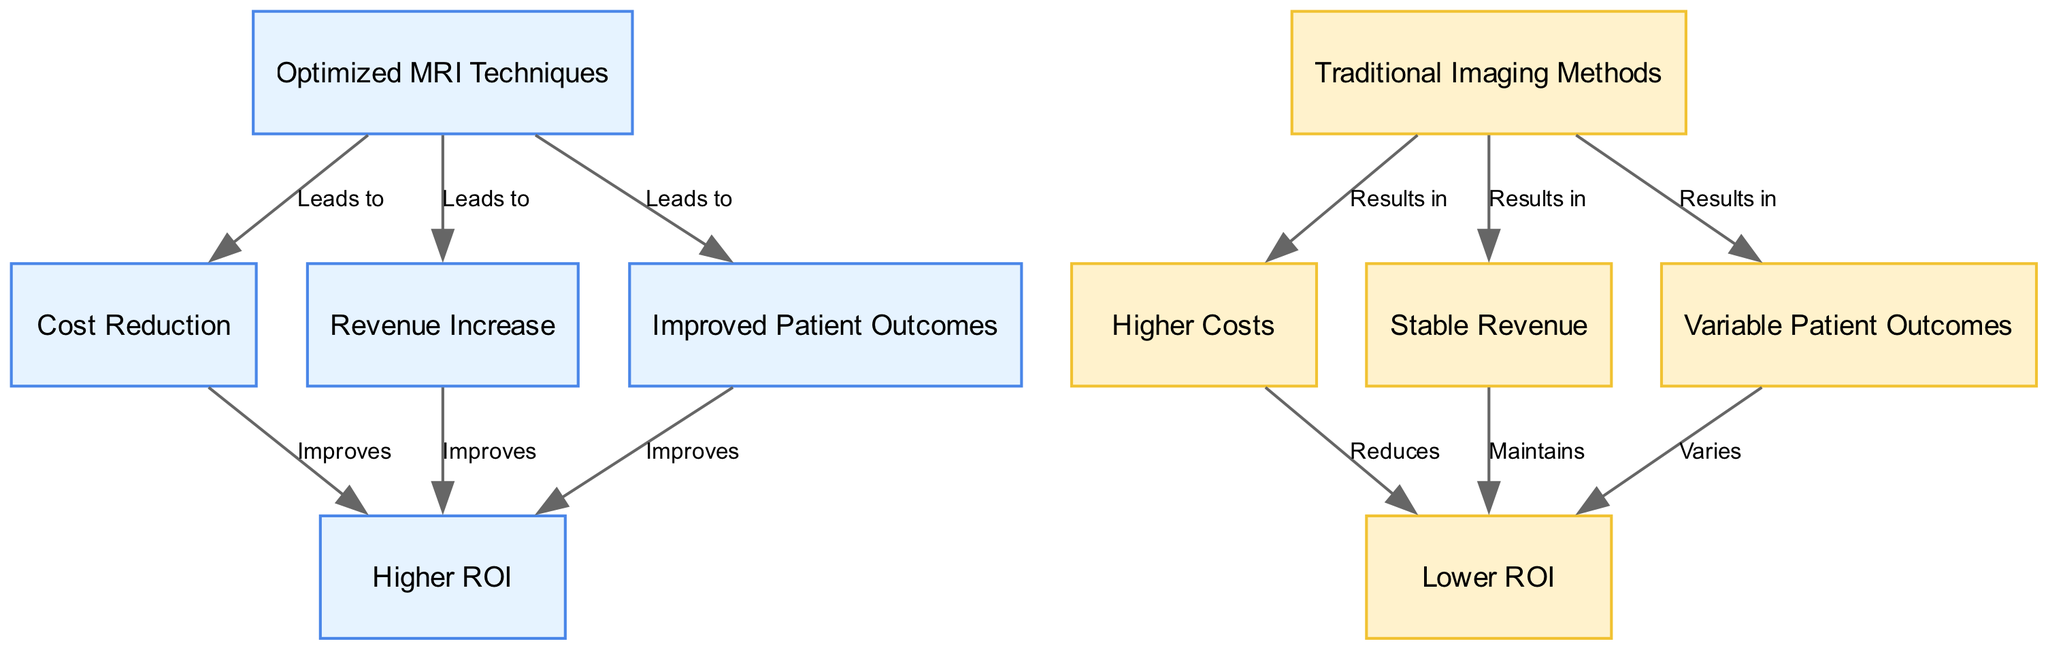What are the implications of optimized MRI techniques on patient outcomes? The diagram indicates that optimized MRI techniques directly lead to improved patient outcomes, suggesting that these techniques enhance the quality of care patients receive compared to traditional methods.
Answer: Improved Patient Outcomes How many nodes represent the traditional imaging methods? There are three nodes related to traditional imaging methods: higher costs, stable revenue, and variable patient outcomes. This is evident when counting the nodes that specifically mention "traditional."
Answer: 3 What is the relationship between cost reduction and ROI for optimized MRI techniques? The diagram shows that cost reduction from optimized MRI techniques improves ROI, indicating a positive correlation between reduced costs and returns on investment.
Answer: Improves What does the revenue increase from optimized MRI techniques lead to? According to the diagram, a revenue increase from optimized MRI techniques also improves ROI, demonstrating that higher revenues directly contribute to better returns.
Answer: Improves What is the impact of higher costs associated with traditional imaging methods on ROI? The diagram indicates that higher costs associated with traditional imaging methods reduce ROI, showing that increased expenses negatively impact returns.
Answer: Reduces How does the variable patient outcomes of traditional imaging methods affect ROI? The diagram states that variable patient outcomes from traditional imaging methods vary the ROI, implying that inconsistent results lead to unpredictable returns on investment.
Answer: Varies Which node has a direct impact on both revenue and outcomes for optimized MRI techniques? The diagram indicates that optimized MRI techniques lead to both revenue increase and improved patient outcomes, showing their multifaceted benefits.
Answer: Revenue Increase How does the ROI for traditional imaging methods compare to that of optimized MRI techniques? The diagram clearly shows that ROI for optimized MRI techniques is higher compared to the lower ROI from traditional imaging methods, highlighting the advantage of optimized approaches.
Answer: Higher ROI What color is used to represent the ROI nodes in the diagram? In the diagram, the ROI nodes are represented in the color green, which typically signifies positive outcomes and benefits.
Answer: Green 